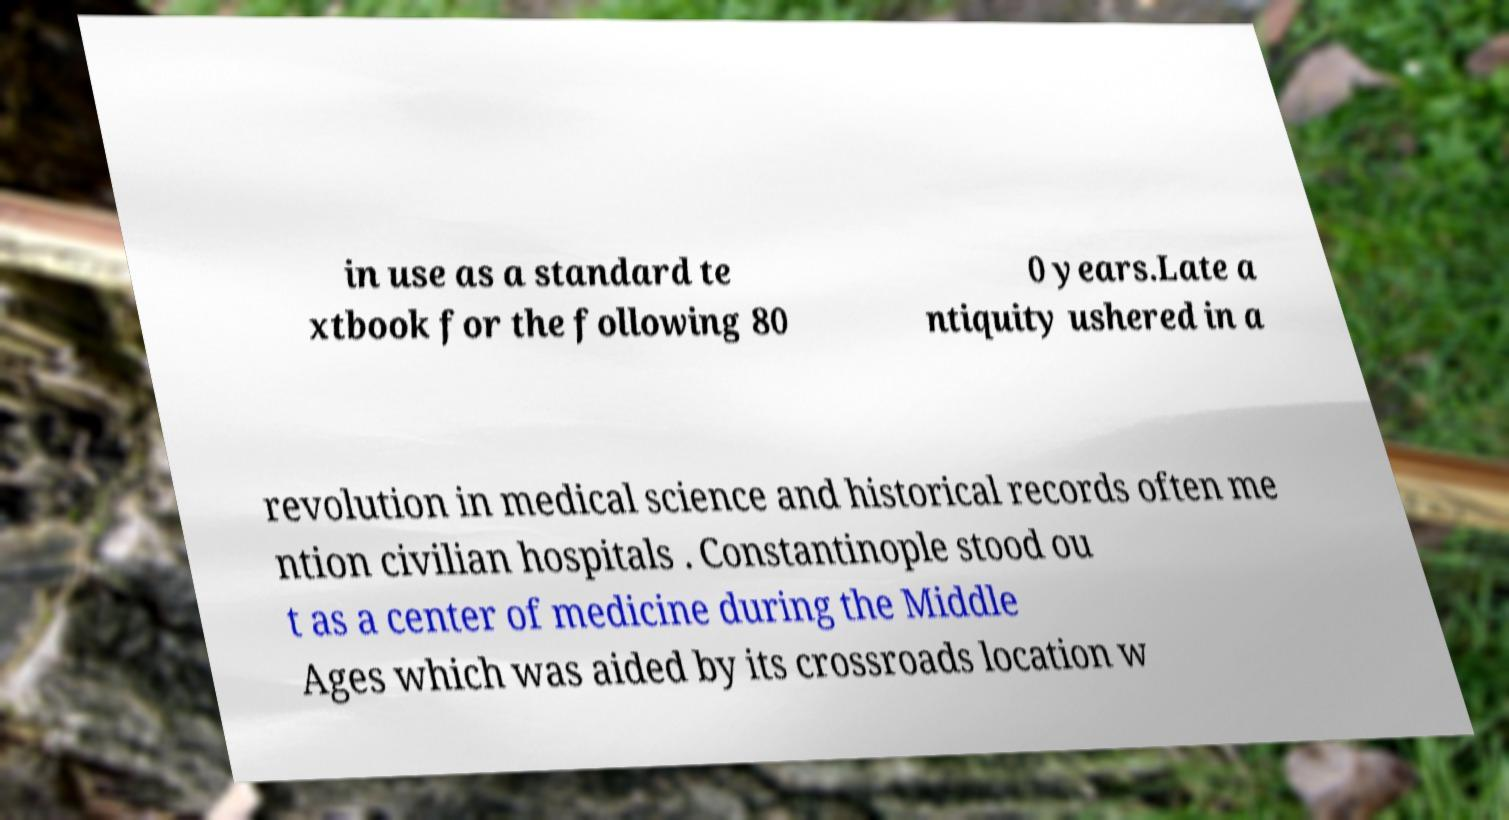I need the written content from this picture converted into text. Can you do that? in use as a standard te xtbook for the following 80 0 years.Late a ntiquity ushered in a revolution in medical science and historical records often me ntion civilian hospitals . Constantinople stood ou t as a center of medicine during the Middle Ages which was aided by its crossroads location w 